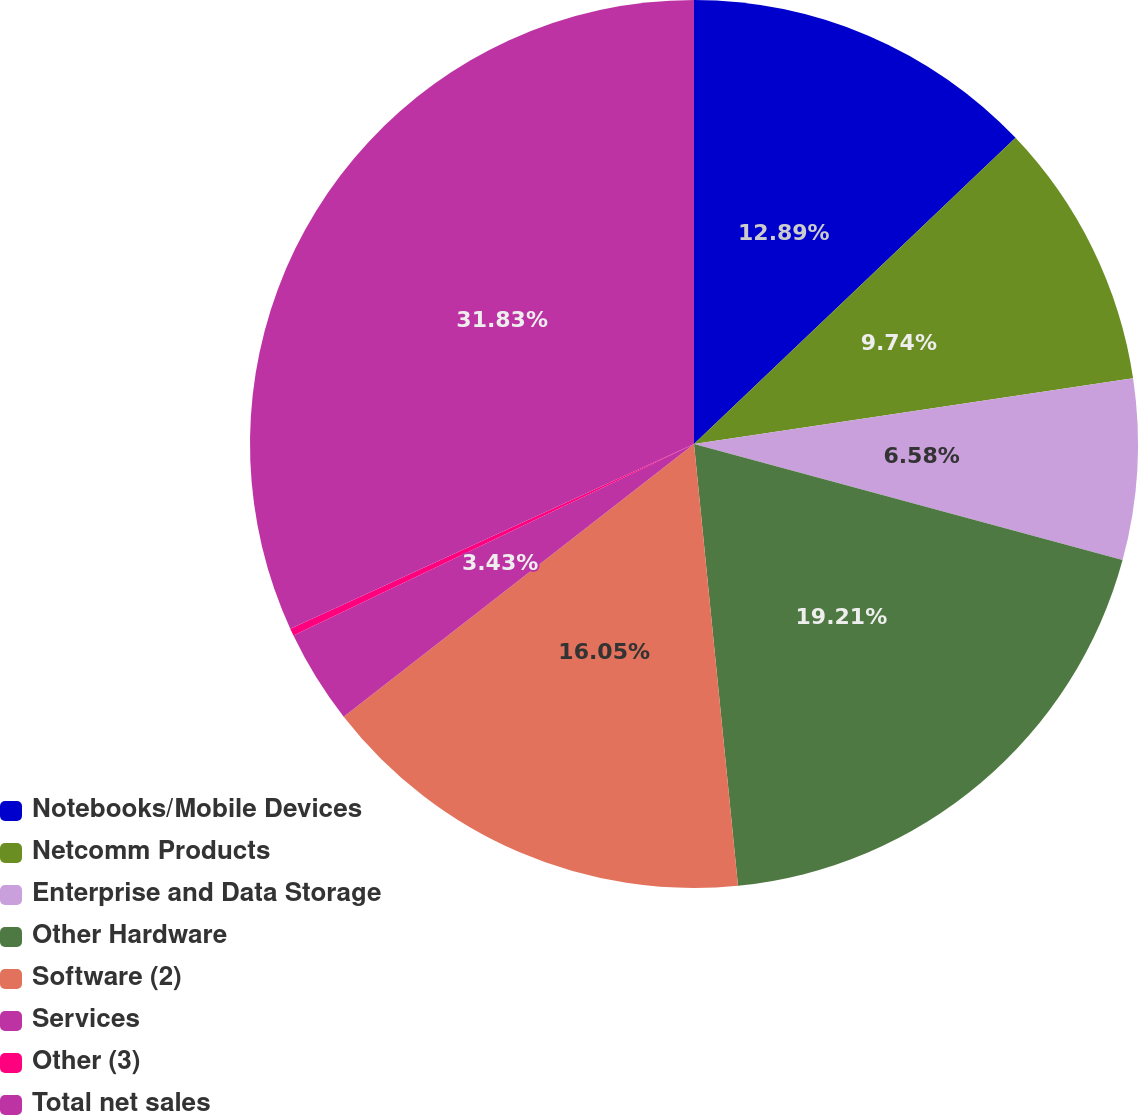<chart> <loc_0><loc_0><loc_500><loc_500><pie_chart><fcel>Notebooks/Mobile Devices<fcel>Netcomm Products<fcel>Enterprise and Data Storage<fcel>Other Hardware<fcel>Software (2)<fcel>Services<fcel>Other (3)<fcel>Total net sales<nl><fcel>12.89%<fcel>9.74%<fcel>6.58%<fcel>19.21%<fcel>16.05%<fcel>3.43%<fcel>0.27%<fcel>31.83%<nl></chart> 